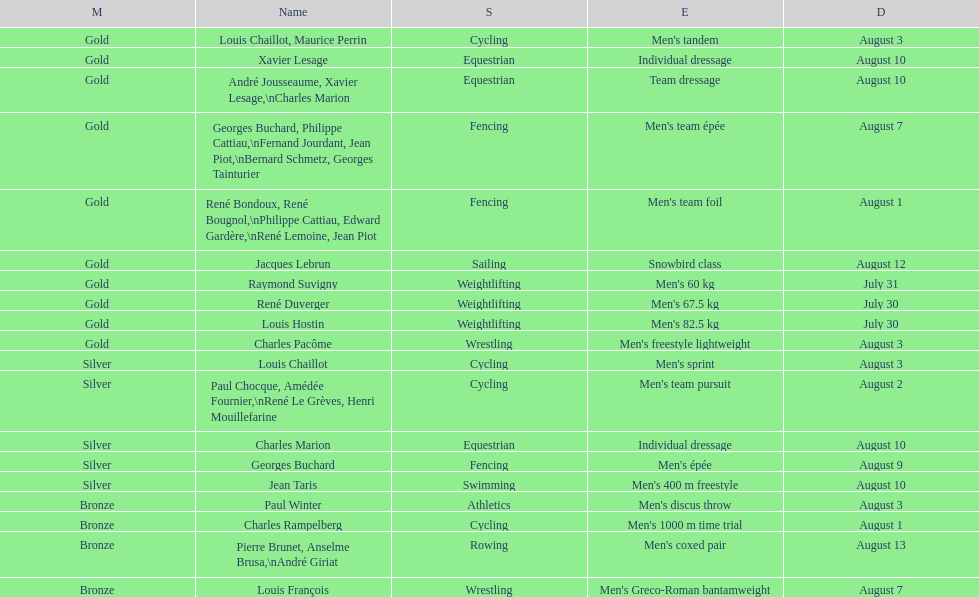How many medals were won after august 3? 9. 